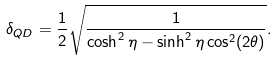<formula> <loc_0><loc_0><loc_500><loc_500>\delta _ { Q D } = \frac { 1 } { 2 } \sqrt { \frac { 1 } { \cosh ^ { 2 } \eta - \sinh ^ { 2 } \eta \cos ^ { 2 } ( 2 \theta ) } } .</formula> 